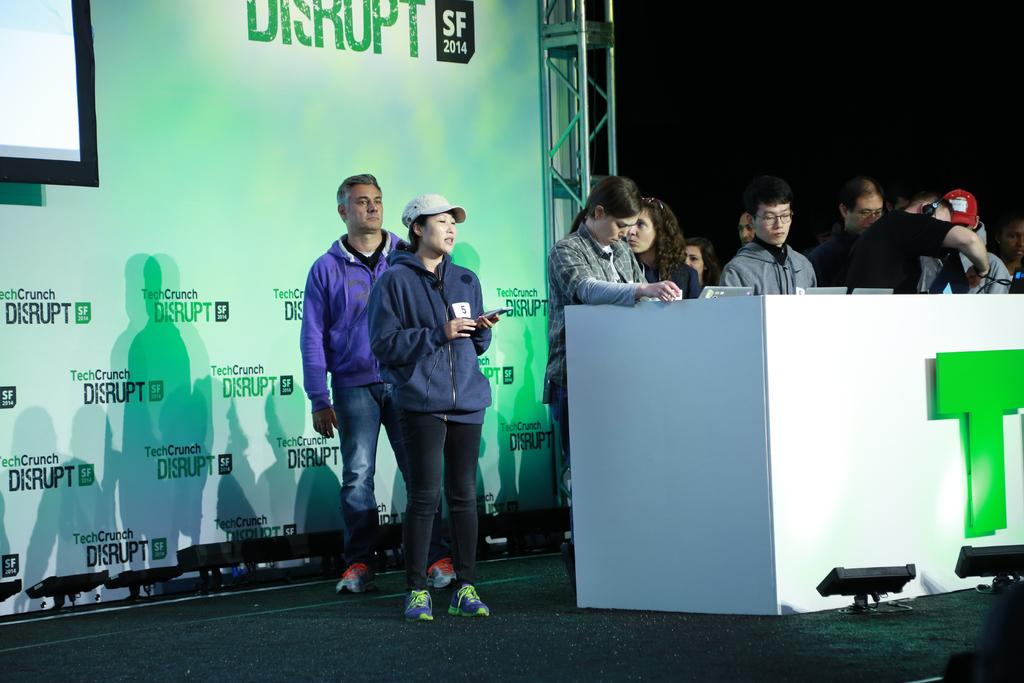How many people are in the image? There are persons standing in the image. What is in front of the persons? There is a table in front of the persons. What is placed on the table? There are laptops placed on the table. What can be seen behind the persons? There is a banner behind the persons. What is written on the banner? The banner has something written on it. How many sisters are standing next to each other in the image? There is no mention of sisters in the image, and the number of persons cannot be determined from the provided facts. 